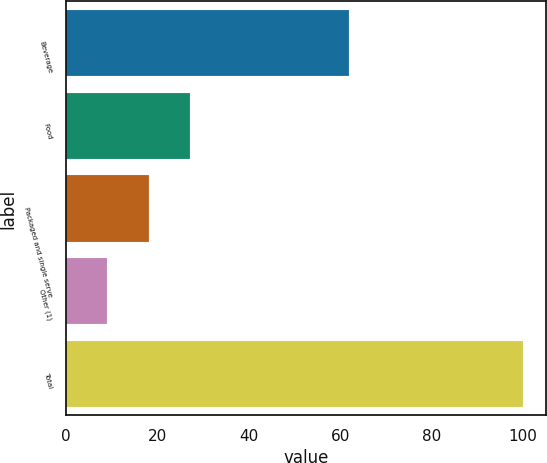Convert chart to OTSL. <chart><loc_0><loc_0><loc_500><loc_500><bar_chart><fcel>Beverage<fcel>Food<fcel>Packaged and single serve<fcel>Other (1)<fcel>Total<nl><fcel>62<fcel>27.2<fcel>18.1<fcel>9<fcel>100<nl></chart> 